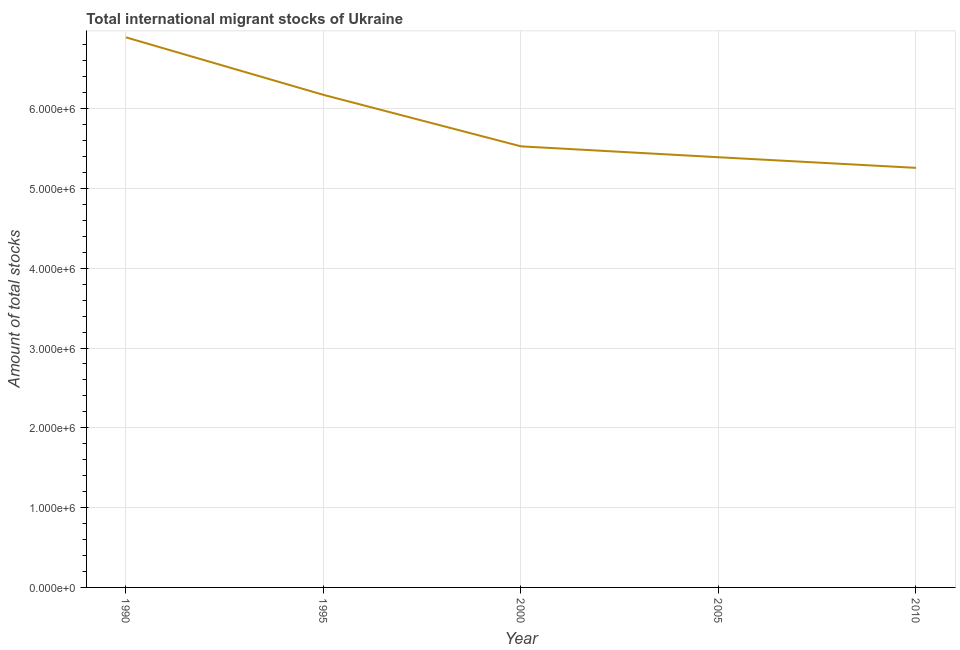What is the total number of international migrant stock in 2000?
Give a very brief answer. 5.53e+06. Across all years, what is the maximum total number of international migrant stock?
Keep it short and to the point. 6.89e+06. Across all years, what is the minimum total number of international migrant stock?
Your answer should be compact. 5.26e+06. In which year was the total number of international migrant stock maximum?
Ensure brevity in your answer.  1990. In which year was the total number of international migrant stock minimum?
Keep it short and to the point. 2010. What is the sum of the total number of international migrant stock?
Provide a succinct answer. 2.92e+07. What is the difference between the total number of international migrant stock in 2000 and 2005?
Offer a terse response. 1.36e+05. What is the average total number of international migrant stock per year?
Make the answer very short. 5.85e+06. What is the median total number of international migrant stock?
Offer a very short reply. 5.53e+06. What is the ratio of the total number of international migrant stock in 1995 to that in 2005?
Give a very brief answer. 1.15. Is the total number of international migrant stock in 1995 less than that in 2000?
Offer a terse response. No. Is the difference between the total number of international migrant stock in 2000 and 2005 greater than the difference between any two years?
Provide a succinct answer. No. What is the difference between the highest and the second highest total number of international migrant stock?
Your response must be concise. 7.21e+05. Is the sum of the total number of international migrant stock in 1990 and 1995 greater than the maximum total number of international migrant stock across all years?
Ensure brevity in your answer.  Yes. What is the difference between the highest and the lowest total number of international migrant stock?
Provide a succinct answer. 1.64e+06. Does the total number of international migrant stock monotonically increase over the years?
Your answer should be very brief. No. How many years are there in the graph?
Provide a short and direct response. 5. What is the title of the graph?
Make the answer very short. Total international migrant stocks of Ukraine. What is the label or title of the Y-axis?
Provide a succinct answer. Amount of total stocks. What is the Amount of total stocks of 1990?
Provide a succinct answer. 6.89e+06. What is the Amount of total stocks in 1995?
Provide a succinct answer. 6.17e+06. What is the Amount of total stocks of 2000?
Your response must be concise. 5.53e+06. What is the Amount of total stocks in 2005?
Provide a succinct answer. 5.39e+06. What is the Amount of total stocks of 2010?
Keep it short and to the point. 5.26e+06. What is the difference between the Amount of total stocks in 1990 and 1995?
Offer a terse response. 7.21e+05. What is the difference between the Amount of total stocks in 1990 and 2000?
Make the answer very short. 1.37e+06. What is the difference between the Amount of total stocks in 1990 and 2005?
Your answer should be compact. 1.50e+06. What is the difference between the Amount of total stocks in 1990 and 2010?
Provide a short and direct response. 1.64e+06. What is the difference between the Amount of total stocks in 1995 and 2000?
Your answer should be compact. 6.45e+05. What is the difference between the Amount of total stocks in 1995 and 2005?
Your answer should be very brief. 7.82e+05. What is the difference between the Amount of total stocks in 1995 and 2010?
Provide a short and direct response. 9.15e+05. What is the difference between the Amount of total stocks in 2000 and 2005?
Provide a succinct answer. 1.36e+05. What is the difference between the Amount of total stocks in 2000 and 2010?
Ensure brevity in your answer.  2.70e+05. What is the difference between the Amount of total stocks in 2005 and 2010?
Ensure brevity in your answer.  1.33e+05. What is the ratio of the Amount of total stocks in 1990 to that in 1995?
Ensure brevity in your answer.  1.12. What is the ratio of the Amount of total stocks in 1990 to that in 2000?
Ensure brevity in your answer.  1.25. What is the ratio of the Amount of total stocks in 1990 to that in 2005?
Provide a short and direct response. 1.28. What is the ratio of the Amount of total stocks in 1990 to that in 2010?
Provide a short and direct response. 1.31. What is the ratio of the Amount of total stocks in 1995 to that in 2000?
Offer a very short reply. 1.12. What is the ratio of the Amount of total stocks in 1995 to that in 2005?
Keep it short and to the point. 1.15. What is the ratio of the Amount of total stocks in 1995 to that in 2010?
Your response must be concise. 1.17. What is the ratio of the Amount of total stocks in 2000 to that in 2005?
Provide a short and direct response. 1.02. What is the ratio of the Amount of total stocks in 2000 to that in 2010?
Offer a very short reply. 1.05. 